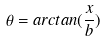Convert formula to latex. <formula><loc_0><loc_0><loc_500><loc_500>\theta = a r c t a n ( \frac { x } { b } )</formula> 